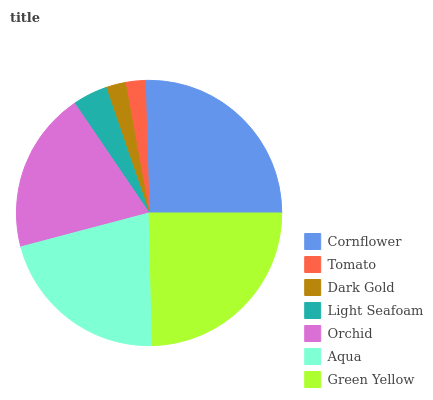Is Dark Gold the minimum?
Answer yes or no. Yes. Is Cornflower the maximum?
Answer yes or no. Yes. Is Tomato the minimum?
Answer yes or no. No. Is Tomato the maximum?
Answer yes or no. No. Is Cornflower greater than Tomato?
Answer yes or no. Yes. Is Tomato less than Cornflower?
Answer yes or no. Yes. Is Tomato greater than Cornflower?
Answer yes or no. No. Is Cornflower less than Tomato?
Answer yes or no. No. Is Orchid the high median?
Answer yes or no. Yes. Is Orchid the low median?
Answer yes or no. Yes. Is Tomato the high median?
Answer yes or no. No. Is Green Yellow the low median?
Answer yes or no. No. 